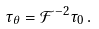Convert formula to latex. <formula><loc_0><loc_0><loc_500><loc_500>\tau _ { \theta } = \mathcal { F } ^ { - 2 } \tau _ { 0 } \, .</formula> 